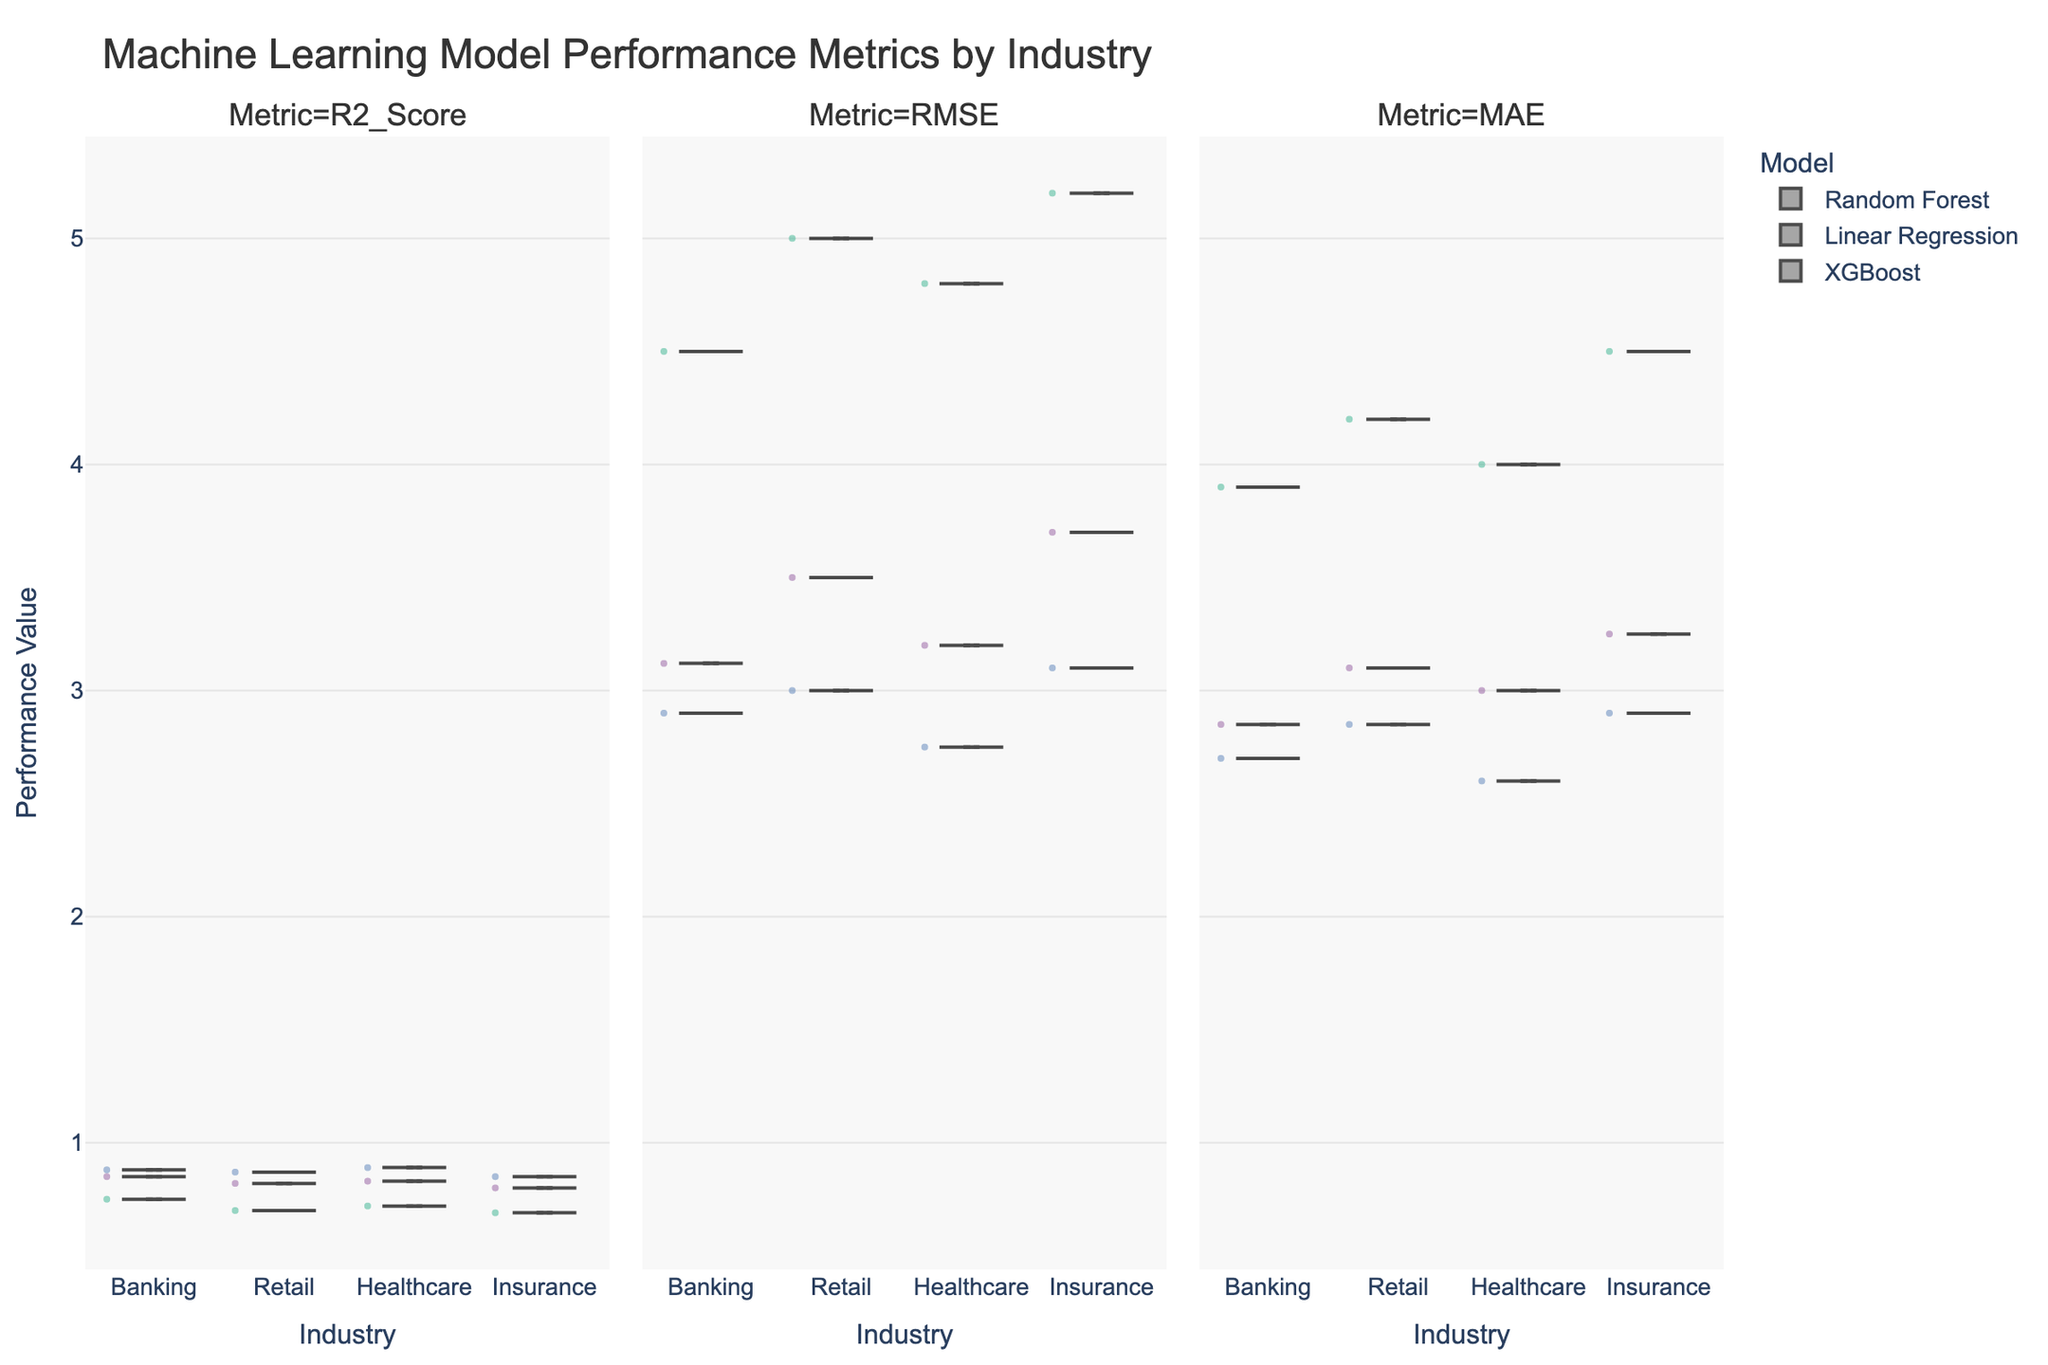What is the title of the figure? The title is usually displayed at the top of the figure, in font larger than the other text. It describes what the figure is about.
Answer: Machine Learning Model Performance Metrics by Industry Which industry has the lowest median RMSE value for XGBoost? To find the lowest median RMSE value for XGBoost, look at the RMSE plot facet and compare the positions of the medians for XGBoost in each industry.
Answer: Healthcare In the Banking industry, which model has the highest R2 score? Focus on the R2_Score facet and compare the medians of the Banking industry data for all models.
Answer: XGBoost Compare the RMSE values for Random Forest in Banking and Retail industries. Which industry shows better performance? Check the RMSE plot facet, locate the Random Forest category, and observe the distribution. The industry with lower overall RMSE values shows better performance.
Answer: Banking How does the MAE for Linear Regression in Insurance compare to that in Healthcare? Compare the MAE values for Linear Regression between Insurance and Healthcare. Locate the MAE facet and observe the respective medians and distributions.
Answer: Higher in Insurance Which metric shows the largest difference in performance between Random Forest and Linear Regression in the Retail industry? Look at each facet (R2_Score, RMSE, MAE) for the Retail industry and compare the distributions for Random Forest and Linear Regression. Determine which metric has the most significant difference.
Answer: RMSE What can you infer about the variance of MAE values for XGBoost across different industries? Observe the spread and range of MAE values for XGBoost across the industries in the MAE plot facet. Consider if the values are close together (low variance) or widely spread (high variance).
Answer: Variance is low across different industries Which model generally performs best in the Healthcare industry based on R2 scores? Look at the R2_Score plot facet and compare the median and overall distributions for Healthcare for each model. The model with the highest median R2 score generally performs best.
Answer: XGBoost Are there any industries where Linear Regression outperforms any other model in any metric? Compare all three metrics (R2_Score, RMSE, MAE) for Linear Regression against Random Forest and XGBoost in each industry. See if Linear Regression outperforms in any of these cases.
Answer: No 